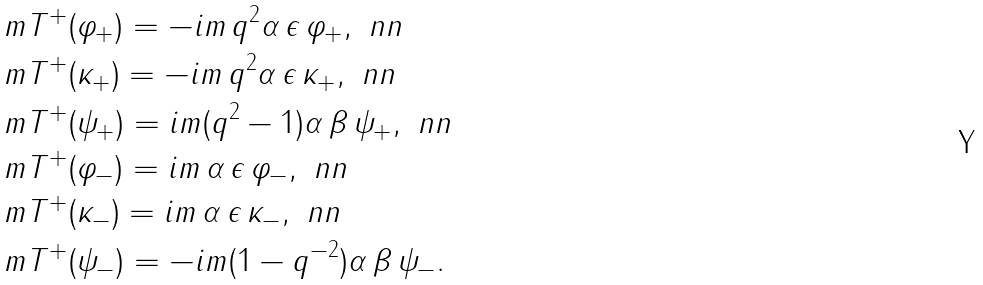Convert formula to latex. <formula><loc_0><loc_0><loc_500><loc_500>& \ m T ^ { + } ( \varphi _ { + } ) = - i m \, q ^ { 2 } \alpha \, \epsilon \, \varphi _ { + } , \ n n \\ & \ m T ^ { + } ( \kappa _ { + } ) = - i m \, q ^ { 2 } \alpha \, \epsilon \, \kappa _ { + } , \ n n \\ & \ m T ^ { + } ( \psi _ { + } ) = i m ( q ^ { 2 } - 1 ) \alpha \, \beta \, \psi _ { + } , \ n n \\ & \ m T ^ { + } ( \varphi _ { - } ) = i m \, \alpha \, \epsilon \, \varphi _ { - } , \ n n \\ & \ m T ^ { + } ( \kappa _ { - } ) = i m \, \alpha \, \epsilon \, \kappa _ { - } , \ n n \\ & \ m T ^ { + } ( \psi _ { - } ) = - i m ( 1 - q ^ { - 2 } ) \alpha \, \beta \, \psi _ { - } .</formula> 